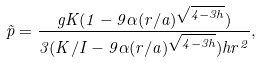Convert formula to latex. <formula><loc_0><loc_0><loc_500><loc_500>\tilde { p } = \frac { g K ( 1 - 9 \alpha ( r / a ) ^ { \sqrt { 4 - 3 h } } ) } { 3 ( K / I - 9 \alpha ( r / a ) ^ { \sqrt { 4 - 3 h } } ) h r ^ { 2 } } ,</formula> 